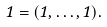<formula> <loc_0><loc_0><loc_500><loc_500>1 = ( 1 , \dots , 1 ) .</formula> 